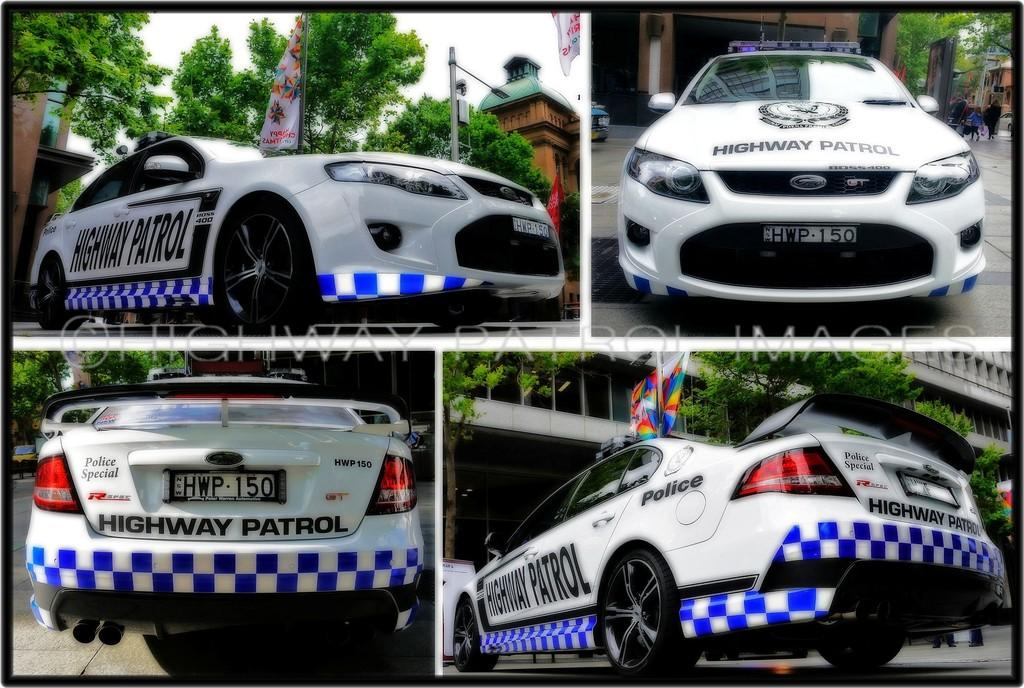What is the main subject of the collage image in the picture? The main subject of the collage image is a police car on the road. What can be seen on the police car? There are texts written on the police car. Who or what can be seen in the image besides the police car? There are people visible in the image. What type of natural elements are present in the image? There are trees in the image. What other man-made structures can be seen in the image? There are flags, a street light pole, and a building in the image. What flavor of ice cream is being enjoyed by the police car in the image? There is no ice cream present in the image, and the police car is not enjoying any flavor. 